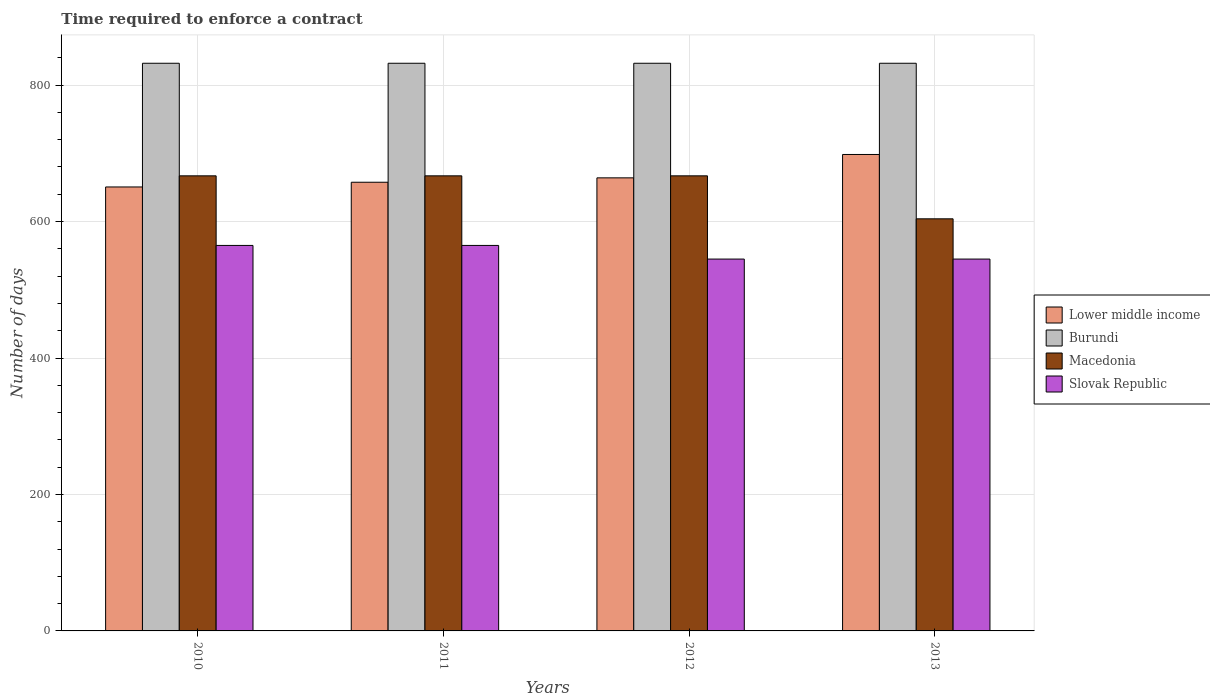Are the number of bars on each tick of the X-axis equal?
Keep it short and to the point. Yes. How many bars are there on the 4th tick from the left?
Offer a very short reply. 4. What is the label of the 4th group of bars from the left?
Make the answer very short. 2013. In how many cases, is the number of bars for a given year not equal to the number of legend labels?
Offer a very short reply. 0. What is the number of days required to enforce a contract in Lower middle income in 2012?
Offer a very short reply. 664.04. Across all years, what is the maximum number of days required to enforce a contract in Burundi?
Give a very brief answer. 832. Across all years, what is the minimum number of days required to enforce a contract in Lower middle income?
Give a very brief answer. 650.69. In which year was the number of days required to enforce a contract in Burundi minimum?
Your answer should be compact. 2010. What is the total number of days required to enforce a contract in Burundi in the graph?
Your response must be concise. 3328. What is the difference between the number of days required to enforce a contract in Lower middle income in 2012 and that in 2013?
Give a very brief answer. -34.25. What is the difference between the number of days required to enforce a contract in Lower middle income in 2010 and the number of days required to enforce a contract in Macedonia in 2013?
Ensure brevity in your answer.  46.69. What is the average number of days required to enforce a contract in Macedonia per year?
Keep it short and to the point. 651.25. In the year 2011, what is the difference between the number of days required to enforce a contract in Macedonia and number of days required to enforce a contract in Burundi?
Ensure brevity in your answer.  -165. In how many years, is the number of days required to enforce a contract in Burundi greater than 200 days?
Your answer should be very brief. 4. What is the ratio of the number of days required to enforce a contract in Lower middle income in 2010 to that in 2011?
Your response must be concise. 0.99. Is the number of days required to enforce a contract in Macedonia in 2011 less than that in 2013?
Your answer should be very brief. No. Is the difference between the number of days required to enforce a contract in Macedonia in 2012 and 2013 greater than the difference between the number of days required to enforce a contract in Burundi in 2012 and 2013?
Give a very brief answer. Yes. What is the difference between the highest and the second highest number of days required to enforce a contract in Lower middle income?
Your answer should be very brief. 34.25. In how many years, is the number of days required to enforce a contract in Slovak Republic greater than the average number of days required to enforce a contract in Slovak Republic taken over all years?
Make the answer very short. 2. Is the sum of the number of days required to enforce a contract in Macedonia in 2011 and 2013 greater than the maximum number of days required to enforce a contract in Lower middle income across all years?
Offer a terse response. Yes. What does the 2nd bar from the left in 2012 represents?
Offer a very short reply. Burundi. What does the 3rd bar from the right in 2013 represents?
Provide a short and direct response. Burundi. Is it the case that in every year, the sum of the number of days required to enforce a contract in Slovak Republic and number of days required to enforce a contract in Lower middle income is greater than the number of days required to enforce a contract in Burundi?
Offer a very short reply. Yes. How many bars are there?
Your answer should be compact. 16. What is the difference between two consecutive major ticks on the Y-axis?
Offer a very short reply. 200. Are the values on the major ticks of Y-axis written in scientific E-notation?
Your answer should be compact. No. Does the graph contain any zero values?
Make the answer very short. No. How many legend labels are there?
Keep it short and to the point. 4. What is the title of the graph?
Your response must be concise. Time required to enforce a contract. Does "Pacific island small states" appear as one of the legend labels in the graph?
Make the answer very short. No. What is the label or title of the X-axis?
Provide a succinct answer. Years. What is the label or title of the Y-axis?
Make the answer very short. Number of days. What is the Number of days of Lower middle income in 2010?
Ensure brevity in your answer.  650.69. What is the Number of days in Burundi in 2010?
Offer a terse response. 832. What is the Number of days of Macedonia in 2010?
Provide a short and direct response. 667. What is the Number of days of Slovak Republic in 2010?
Provide a succinct answer. 565. What is the Number of days of Lower middle income in 2011?
Ensure brevity in your answer.  657.6. What is the Number of days of Burundi in 2011?
Keep it short and to the point. 832. What is the Number of days of Macedonia in 2011?
Offer a terse response. 667. What is the Number of days of Slovak Republic in 2011?
Offer a very short reply. 565. What is the Number of days in Lower middle income in 2012?
Keep it short and to the point. 664.04. What is the Number of days of Burundi in 2012?
Your answer should be very brief. 832. What is the Number of days in Macedonia in 2012?
Provide a short and direct response. 667. What is the Number of days of Slovak Republic in 2012?
Your answer should be very brief. 545. What is the Number of days in Lower middle income in 2013?
Offer a very short reply. 698.29. What is the Number of days of Burundi in 2013?
Give a very brief answer. 832. What is the Number of days of Macedonia in 2013?
Offer a very short reply. 604. What is the Number of days of Slovak Republic in 2013?
Give a very brief answer. 545. Across all years, what is the maximum Number of days in Lower middle income?
Give a very brief answer. 698.29. Across all years, what is the maximum Number of days of Burundi?
Make the answer very short. 832. Across all years, what is the maximum Number of days in Macedonia?
Offer a terse response. 667. Across all years, what is the maximum Number of days of Slovak Republic?
Your answer should be very brief. 565. Across all years, what is the minimum Number of days of Lower middle income?
Provide a succinct answer. 650.69. Across all years, what is the minimum Number of days in Burundi?
Ensure brevity in your answer.  832. Across all years, what is the minimum Number of days of Macedonia?
Provide a succinct answer. 604. Across all years, what is the minimum Number of days in Slovak Republic?
Make the answer very short. 545. What is the total Number of days of Lower middle income in the graph?
Keep it short and to the point. 2670.63. What is the total Number of days in Burundi in the graph?
Give a very brief answer. 3328. What is the total Number of days in Macedonia in the graph?
Keep it short and to the point. 2605. What is the total Number of days of Slovak Republic in the graph?
Offer a very short reply. 2220. What is the difference between the Number of days in Lower middle income in 2010 and that in 2011?
Offer a very short reply. -6.91. What is the difference between the Number of days in Burundi in 2010 and that in 2011?
Keep it short and to the point. 0. What is the difference between the Number of days of Slovak Republic in 2010 and that in 2011?
Your answer should be compact. 0. What is the difference between the Number of days of Lower middle income in 2010 and that in 2012?
Your response must be concise. -13.35. What is the difference between the Number of days of Burundi in 2010 and that in 2012?
Your answer should be compact. 0. What is the difference between the Number of days of Macedonia in 2010 and that in 2012?
Provide a short and direct response. 0. What is the difference between the Number of days in Slovak Republic in 2010 and that in 2012?
Your response must be concise. 20. What is the difference between the Number of days of Lower middle income in 2010 and that in 2013?
Provide a succinct answer. -47.61. What is the difference between the Number of days in Lower middle income in 2011 and that in 2012?
Make the answer very short. -6.44. What is the difference between the Number of days of Burundi in 2011 and that in 2012?
Provide a short and direct response. 0. What is the difference between the Number of days in Slovak Republic in 2011 and that in 2012?
Provide a short and direct response. 20. What is the difference between the Number of days of Lower middle income in 2011 and that in 2013?
Ensure brevity in your answer.  -40.69. What is the difference between the Number of days of Burundi in 2011 and that in 2013?
Your response must be concise. 0. What is the difference between the Number of days in Slovak Republic in 2011 and that in 2013?
Your answer should be compact. 20. What is the difference between the Number of days of Lower middle income in 2012 and that in 2013?
Your answer should be compact. -34.25. What is the difference between the Number of days of Burundi in 2012 and that in 2013?
Offer a very short reply. 0. What is the difference between the Number of days of Macedonia in 2012 and that in 2013?
Offer a terse response. 63. What is the difference between the Number of days of Slovak Republic in 2012 and that in 2013?
Keep it short and to the point. 0. What is the difference between the Number of days in Lower middle income in 2010 and the Number of days in Burundi in 2011?
Keep it short and to the point. -181.31. What is the difference between the Number of days in Lower middle income in 2010 and the Number of days in Macedonia in 2011?
Offer a terse response. -16.31. What is the difference between the Number of days of Lower middle income in 2010 and the Number of days of Slovak Republic in 2011?
Your response must be concise. 85.69. What is the difference between the Number of days of Burundi in 2010 and the Number of days of Macedonia in 2011?
Ensure brevity in your answer.  165. What is the difference between the Number of days in Burundi in 2010 and the Number of days in Slovak Republic in 2011?
Give a very brief answer. 267. What is the difference between the Number of days in Macedonia in 2010 and the Number of days in Slovak Republic in 2011?
Keep it short and to the point. 102. What is the difference between the Number of days of Lower middle income in 2010 and the Number of days of Burundi in 2012?
Offer a terse response. -181.31. What is the difference between the Number of days in Lower middle income in 2010 and the Number of days in Macedonia in 2012?
Keep it short and to the point. -16.31. What is the difference between the Number of days of Lower middle income in 2010 and the Number of days of Slovak Republic in 2012?
Provide a short and direct response. 105.69. What is the difference between the Number of days of Burundi in 2010 and the Number of days of Macedonia in 2012?
Offer a very short reply. 165. What is the difference between the Number of days of Burundi in 2010 and the Number of days of Slovak Republic in 2012?
Ensure brevity in your answer.  287. What is the difference between the Number of days in Macedonia in 2010 and the Number of days in Slovak Republic in 2012?
Ensure brevity in your answer.  122. What is the difference between the Number of days in Lower middle income in 2010 and the Number of days in Burundi in 2013?
Ensure brevity in your answer.  -181.31. What is the difference between the Number of days in Lower middle income in 2010 and the Number of days in Macedonia in 2013?
Give a very brief answer. 46.69. What is the difference between the Number of days in Lower middle income in 2010 and the Number of days in Slovak Republic in 2013?
Ensure brevity in your answer.  105.69. What is the difference between the Number of days in Burundi in 2010 and the Number of days in Macedonia in 2013?
Keep it short and to the point. 228. What is the difference between the Number of days of Burundi in 2010 and the Number of days of Slovak Republic in 2013?
Your answer should be very brief. 287. What is the difference between the Number of days in Macedonia in 2010 and the Number of days in Slovak Republic in 2013?
Make the answer very short. 122. What is the difference between the Number of days of Lower middle income in 2011 and the Number of days of Burundi in 2012?
Make the answer very short. -174.4. What is the difference between the Number of days of Lower middle income in 2011 and the Number of days of Macedonia in 2012?
Ensure brevity in your answer.  -9.4. What is the difference between the Number of days of Lower middle income in 2011 and the Number of days of Slovak Republic in 2012?
Offer a very short reply. 112.6. What is the difference between the Number of days of Burundi in 2011 and the Number of days of Macedonia in 2012?
Offer a very short reply. 165. What is the difference between the Number of days in Burundi in 2011 and the Number of days in Slovak Republic in 2012?
Provide a succinct answer. 287. What is the difference between the Number of days of Macedonia in 2011 and the Number of days of Slovak Republic in 2012?
Give a very brief answer. 122. What is the difference between the Number of days in Lower middle income in 2011 and the Number of days in Burundi in 2013?
Make the answer very short. -174.4. What is the difference between the Number of days in Lower middle income in 2011 and the Number of days in Macedonia in 2013?
Your answer should be compact. 53.6. What is the difference between the Number of days of Lower middle income in 2011 and the Number of days of Slovak Republic in 2013?
Your answer should be very brief. 112.6. What is the difference between the Number of days in Burundi in 2011 and the Number of days in Macedonia in 2013?
Make the answer very short. 228. What is the difference between the Number of days of Burundi in 2011 and the Number of days of Slovak Republic in 2013?
Your response must be concise. 287. What is the difference between the Number of days in Macedonia in 2011 and the Number of days in Slovak Republic in 2013?
Your answer should be compact. 122. What is the difference between the Number of days in Lower middle income in 2012 and the Number of days in Burundi in 2013?
Your answer should be very brief. -167.96. What is the difference between the Number of days in Lower middle income in 2012 and the Number of days in Macedonia in 2013?
Your response must be concise. 60.04. What is the difference between the Number of days in Lower middle income in 2012 and the Number of days in Slovak Republic in 2013?
Provide a succinct answer. 119.04. What is the difference between the Number of days of Burundi in 2012 and the Number of days of Macedonia in 2013?
Ensure brevity in your answer.  228. What is the difference between the Number of days of Burundi in 2012 and the Number of days of Slovak Republic in 2013?
Your response must be concise. 287. What is the difference between the Number of days in Macedonia in 2012 and the Number of days in Slovak Republic in 2013?
Provide a short and direct response. 122. What is the average Number of days in Lower middle income per year?
Keep it short and to the point. 667.66. What is the average Number of days of Burundi per year?
Ensure brevity in your answer.  832. What is the average Number of days in Macedonia per year?
Provide a short and direct response. 651.25. What is the average Number of days of Slovak Republic per year?
Provide a short and direct response. 555. In the year 2010, what is the difference between the Number of days in Lower middle income and Number of days in Burundi?
Provide a short and direct response. -181.31. In the year 2010, what is the difference between the Number of days in Lower middle income and Number of days in Macedonia?
Offer a terse response. -16.31. In the year 2010, what is the difference between the Number of days of Lower middle income and Number of days of Slovak Republic?
Keep it short and to the point. 85.69. In the year 2010, what is the difference between the Number of days of Burundi and Number of days of Macedonia?
Your response must be concise. 165. In the year 2010, what is the difference between the Number of days of Burundi and Number of days of Slovak Republic?
Your response must be concise. 267. In the year 2010, what is the difference between the Number of days in Macedonia and Number of days in Slovak Republic?
Offer a terse response. 102. In the year 2011, what is the difference between the Number of days of Lower middle income and Number of days of Burundi?
Provide a succinct answer. -174.4. In the year 2011, what is the difference between the Number of days in Lower middle income and Number of days in Slovak Republic?
Provide a short and direct response. 92.6. In the year 2011, what is the difference between the Number of days of Burundi and Number of days of Macedonia?
Offer a terse response. 165. In the year 2011, what is the difference between the Number of days in Burundi and Number of days in Slovak Republic?
Keep it short and to the point. 267. In the year 2011, what is the difference between the Number of days in Macedonia and Number of days in Slovak Republic?
Your response must be concise. 102. In the year 2012, what is the difference between the Number of days of Lower middle income and Number of days of Burundi?
Your response must be concise. -167.96. In the year 2012, what is the difference between the Number of days in Lower middle income and Number of days in Macedonia?
Your response must be concise. -2.96. In the year 2012, what is the difference between the Number of days in Lower middle income and Number of days in Slovak Republic?
Give a very brief answer. 119.04. In the year 2012, what is the difference between the Number of days of Burundi and Number of days of Macedonia?
Offer a very short reply. 165. In the year 2012, what is the difference between the Number of days in Burundi and Number of days in Slovak Republic?
Your response must be concise. 287. In the year 2012, what is the difference between the Number of days of Macedonia and Number of days of Slovak Republic?
Offer a terse response. 122. In the year 2013, what is the difference between the Number of days in Lower middle income and Number of days in Burundi?
Provide a short and direct response. -133.71. In the year 2013, what is the difference between the Number of days of Lower middle income and Number of days of Macedonia?
Provide a short and direct response. 94.29. In the year 2013, what is the difference between the Number of days of Lower middle income and Number of days of Slovak Republic?
Give a very brief answer. 153.29. In the year 2013, what is the difference between the Number of days in Burundi and Number of days in Macedonia?
Give a very brief answer. 228. In the year 2013, what is the difference between the Number of days in Burundi and Number of days in Slovak Republic?
Offer a terse response. 287. What is the ratio of the Number of days in Lower middle income in 2010 to that in 2011?
Give a very brief answer. 0.99. What is the ratio of the Number of days in Macedonia in 2010 to that in 2011?
Provide a short and direct response. 1. What is the ratio of the Number of days in Lower middle income in 2010 to that in 2012?
Give a very brief answer. 0.98. What is the ratio of the Number of days of Burundi in 2010 to that in 2012?
Your response must be concise. 1. What is the ratio of the Number of days in Macedonia in 2010 to that in 2012?
Give a very brief answer. 1. What is the ratio of the Number of days in Slovak Republic in 2010 to that in 2012?
Provide a short and direct response. 1.04. What is the ratio of the Number of days in Lower middle income in 2010 to that in 2013?
Ensure brevity in your answer.  0.93. What is the ratio of the Number of days of Macedonia in 2010 to that in 2013?
Provide a succinct answer. 1.1. What is the ratio of the Number of days of Slovak Republic in 2010 to that in 2013?
Ensure brevity in your answer.  1.04. What is the ratio of the Number of days of Lower middle income in 2011 to that in 2012?
Ensure brevity in your answer.  0.99. What is the ratio of the Number of days in Macedonia in 2011 to that in 2012?
Your answer should be compact. 1. What is the ratio of the Number of days of Slovak Republic in 2011 to that in 2012?
Make the answer very short. 1.04. What is the ratio of the Number of days in Lower middle income in 2011 to that in 2013?
Your answer should be very brief. 0.94. What is the ratio of the Number of days of Macedonia in 2011 to that in 2013?
Provide a succinct answer. 1.1. What is the ratio of the Number of days in Slovak Republic in 2011 to that in 2013?
Your response must be concise. 1.04. What is the ratio of the Number of days of Lower middle income in 2012 to that in 2013?
Your answer should be very brief. 0.95. What is the ratio of the Number of days of Macedonia in 2012 to that in 2013?
Provide a succinct answer. 1.1. What is the difference between the highest and the second highest Number of days of Lower middle income?
Ensure brevity in your answer.  34.25. What is the difference between the highest and the lowest Number of days in Lower middle income?
Provide a short and direct response. 47.61. What is the difference between the highest and the lowest Number of days of Slovak Republic?
Keep it short and to the point. 20. 